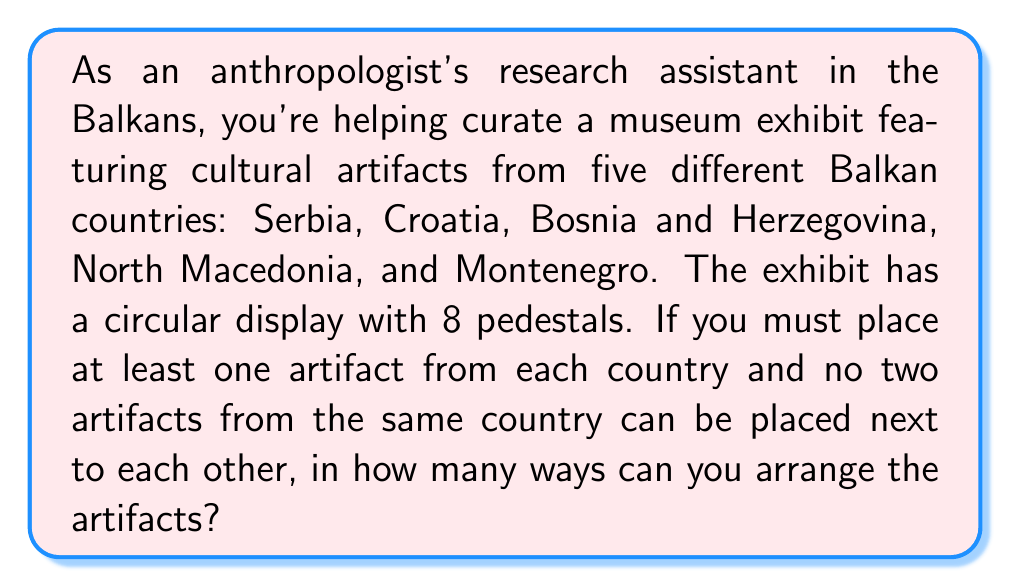Provide a solution to this math problem. Let's approach this step-by-step:

1) First, we need to consider the circular arrangement. In a circular arrangement, rotations are considered the same, so we can fix the position of one country's artifact.

2) Let's fix Serbia's artifact at the first position. Now we have 7 positions to fill.

3) The problem now becomes: In how many ways can we arrange 4 countries (Croatia, Bosnia and Herzegovina, North Macedonia, Montenegro) in 7 positions, with no two countries adjacent to each other?

4) This is a classic circular permutation problem with restrictions. We can solve it using the Inclusion-Exclusion Principle.

5) Let's define:
   $A_i$ = the set of arrangements where countries $i$ and $i+1$ are adjacent

6) The total number of unrestricted arrangements is $P(7,4) = 7 \cdot 6 \cdot 5 \cdot 4 = 840$

7) Using Inclusion-Exclusion:

   $$\text{Valid Arrangements} = 840 - |A_1 \cup A_2 \cup A_3 \cup A_4|$$

8) $|A_i| = 6 \cdot 5 \cdot 4 = 120$ (treating adjacent countries as one unit)

9) $|A_i \cap A_j| = 5 \cdot 4 = 20$ (for non-circular adjacent pairs)

10) $|A_1 \cap A_4| = 5 \cdot 4 = 20$ (for the circular adjacent pair)

11) $|A_i \cap A_j \cap A_k| = 4$ (for any three countries)

12) $|A_1 \cap A_2 \cap A_3 \cap A_4| = 1$

13) Applying Inclusion-Exclusion:

    $$840 - (4 \cdot 120) + (5 \cdot 20) - (4 \cdot 4) + 1 = 840 - 480 + 100 - 16 + 1 = 445$$

Therefore, there are 445 valid arrangements.
Answer: 445 ways 